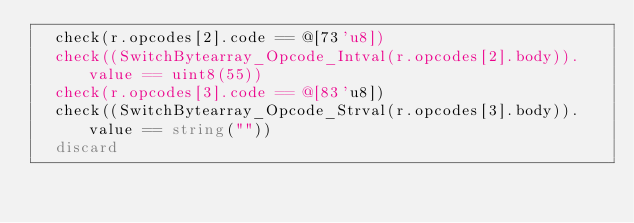Convert code to text. <code><loc_0><loc_0><loc_500><loc_500><_Nim_>  check(r.opcodes[2].code == @[73'u8])
  check((SwitchBytearray_Opcode_Intval(r.opcodes[2].body)).value == uint8(55))
  check(r.opcodes[3].code == @[83'u8])
  check((SwitchBytearray_Opcode_Strval(r.opcodes[3].body)).value == string(""))
  discard
</code> 